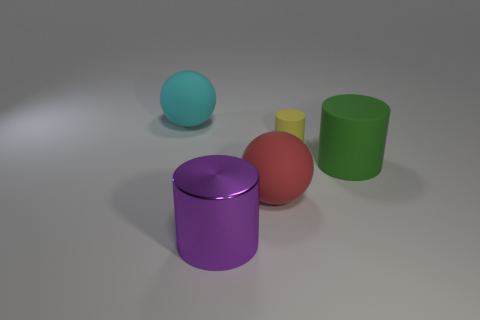Does the small cylinder have the same color as the cylinder that is on the left side of the big red matte object?
Give a very brief answer. No. Is there a small yellow cylinder that is to the left of the big sphere in front of the sphere behind the large red rubber sphere?
Offer a very short reply. No. There is a red object that is made of the same material as the tiny yellow thing; what is its shape?
Your answer should be compact. Sphere. Is there anything else that is the same shape as the big cyan matte object?
Your answer should be compact. Yes. There is a green thing; what shape is it?
Offer a very short reply. Cylinder. There is a large object right of the large red matte thing; is its shape the same as the tiny yellow thing?
Your answer should be very brief. Yes. Is the number of objects that are left of the tiny yellow matte cylinder greater than the number of big matte things that are behind the cyan thing?
Give a very brief answer. Yes. How many other objects are the same size as the purple object?
Provide a succinct answer. 3. Does the tiny yellow matte object have the same shape as the large cyan thing behind the red rubber ball?
Give a very brief answer. No. How many matte objects are green things or large objects?
Ensure brevity in your answer.  3. 